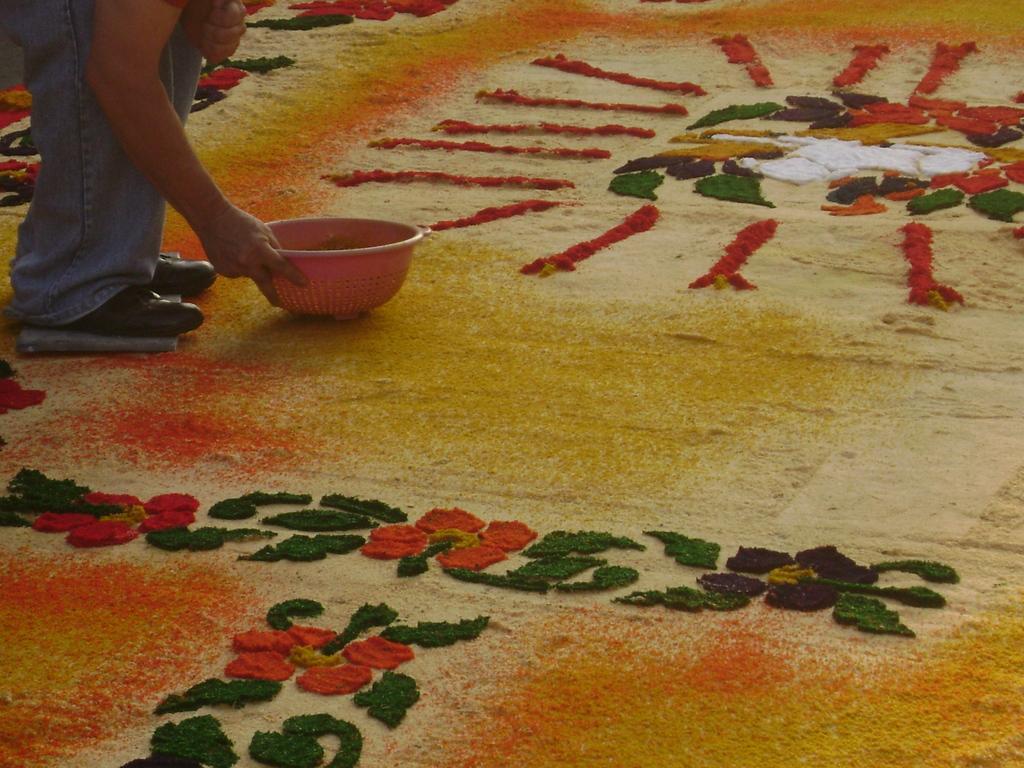How would you summarize this image in a sentence or two? In the picture we can see a person bending and holding a bowl on the floor and he is doing some designs on the floor with colors. 